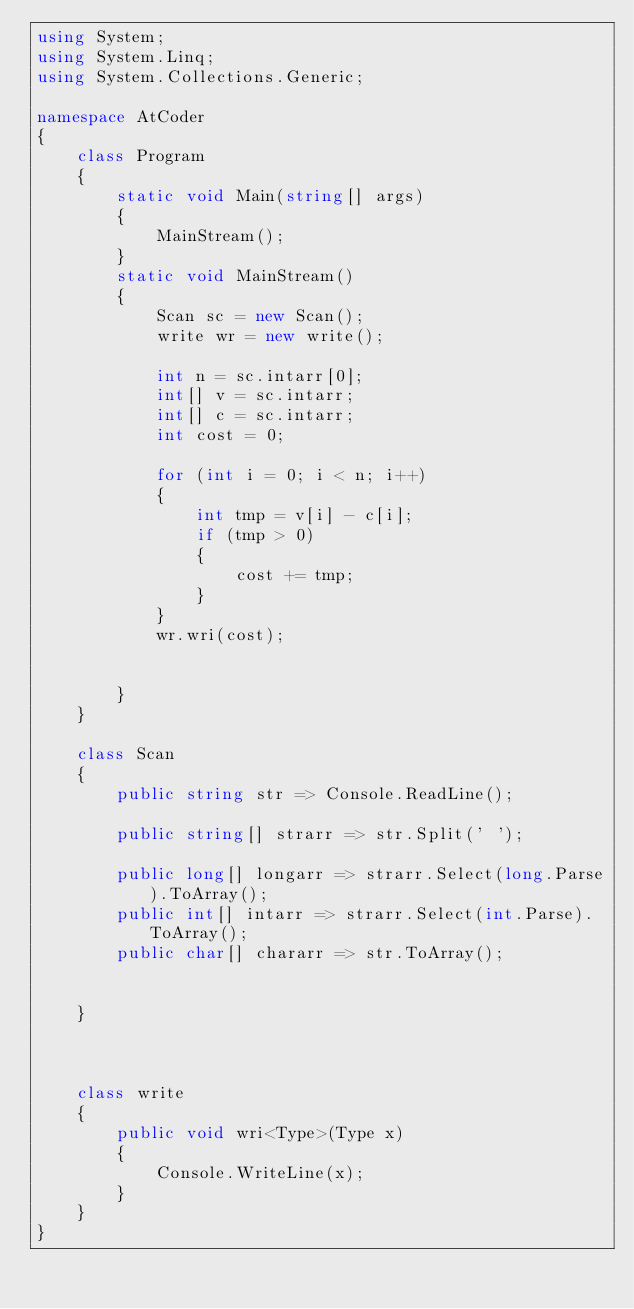Convert code to text. <code><loc_0><loc_0><loc_500><loc_500><_C#_>using System;
using System.Linq;
using System.Collections.Generic;

namespace AtCoder
{
    class Program
    {
        static void Main(string[] args)
        {
            MainStream();
        }
        static void MainStream()
        {
            Scan sc = new Scan();
            write wr = new write();

            int n = sc.intarr[0];
            int[] v = sc.intarr;
            int[] c = sc.intarr;
            int cost = 0;

            for (int i = 0; i < n; i++)
            {
                int tmp = v[i] - c[i];
                if (tmp > 0)
                {
                    cost += tmp;
                }
            }
            wr.wri(cost);


        }
    }

    class Scan
    {
        public string str => Console.ReadLine();

        public string[] strarr => str.Split(' ');

        public long[] longarr => strarr.Select(long.Parse).ToArray();
        public int[] intarr => strarr.Select(int.Parse).ToArray();
        public char[] chararr => str.ToArray();


    }



    class write
    {
        public void wri<Type>(Type x)
        {
            Console.WriteLine(x);
        }
    }
}
</code> 